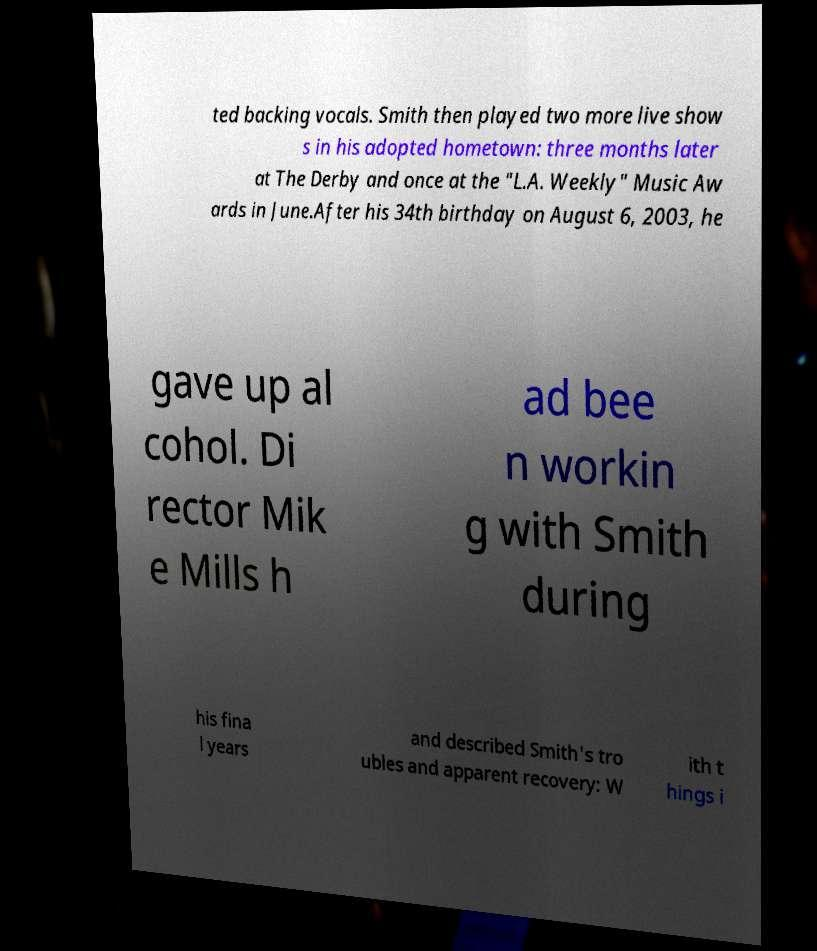I need the written content from this picture converted into text. Can you do that? ted backing vocals. Smith then played two more live show s in his adopted hometown: three months later at The Derby and once at the "L.A. Weekly" Music Aw ards in June.After his 34th birthday on August 6, 2003, he gave up al cohol. Di rector Mik e Mills h ad bee n workin g with Smith during his fina l years and described Smith's tro ubles and apparent recovery: W ith t hings i 